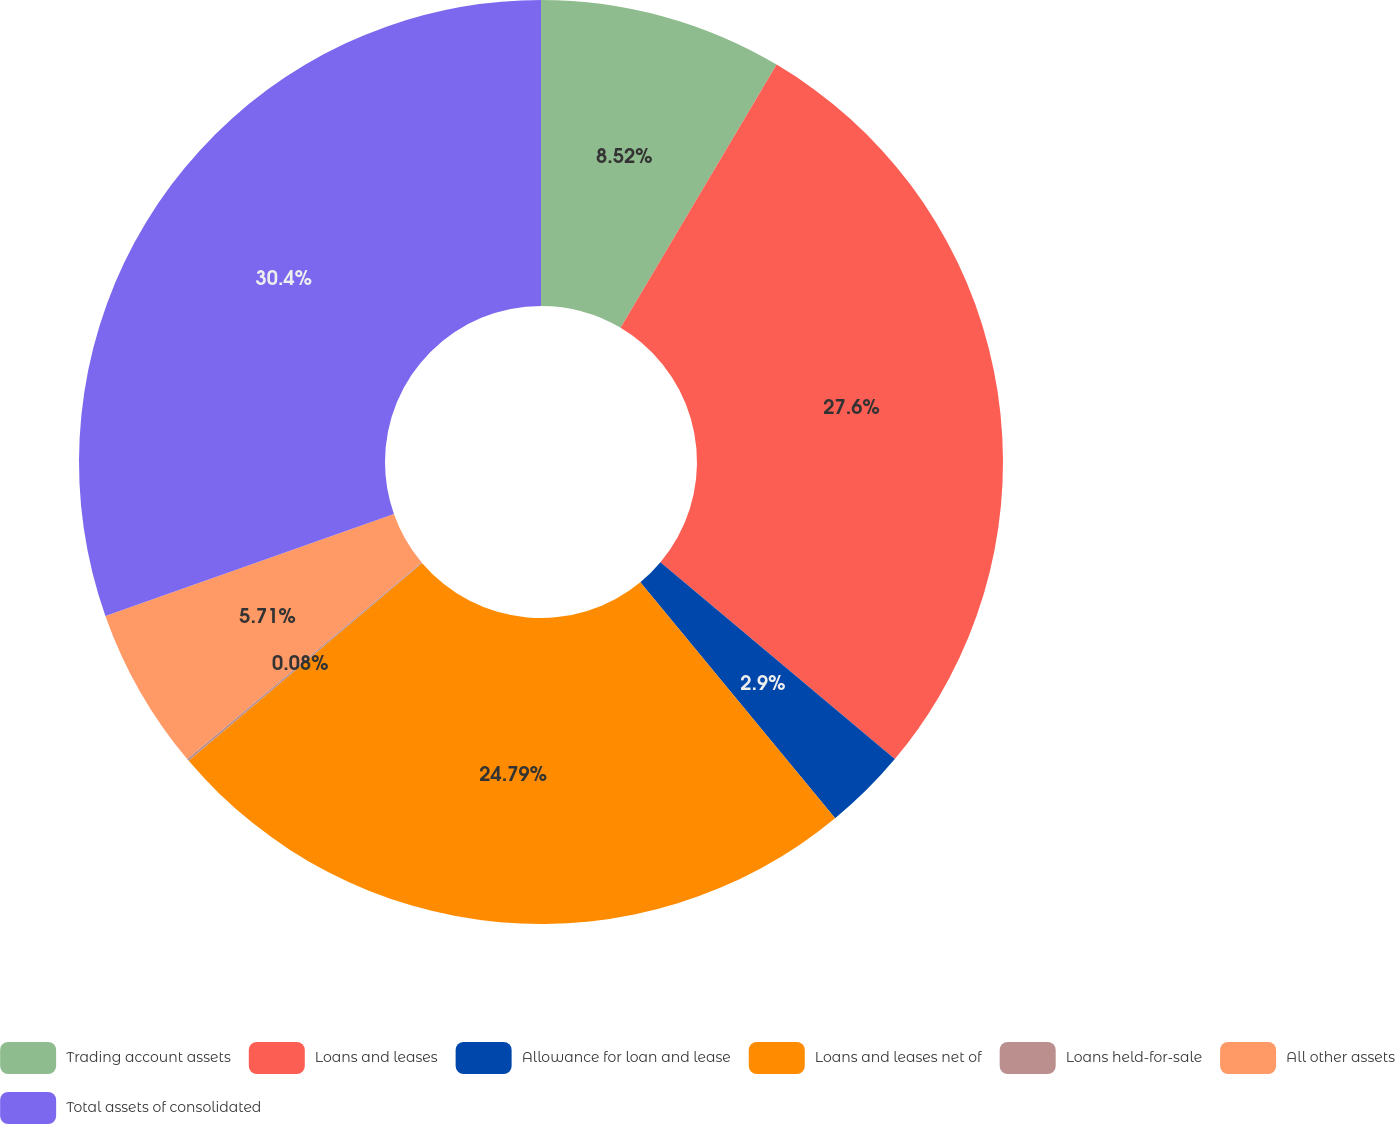Convert chart to OTSL. <chart><loc_0><loc_0><loc_500><loc_500><pie_chart><fcel>Trading account assets<fcel>Loans and leases<fcel>Allowance for loan and lease<fcel>Loans and leases net of<fcel>Loans held-for-sale<fcel>All other assets<fcel>Total assets of consolidated<nl><fcel>8.52%<fcel>27.6%<fcel>2.9%<fcel>24.79%<fcel>0.08%<fcel>5.71%<fcel>30.41%<nl></chart> 